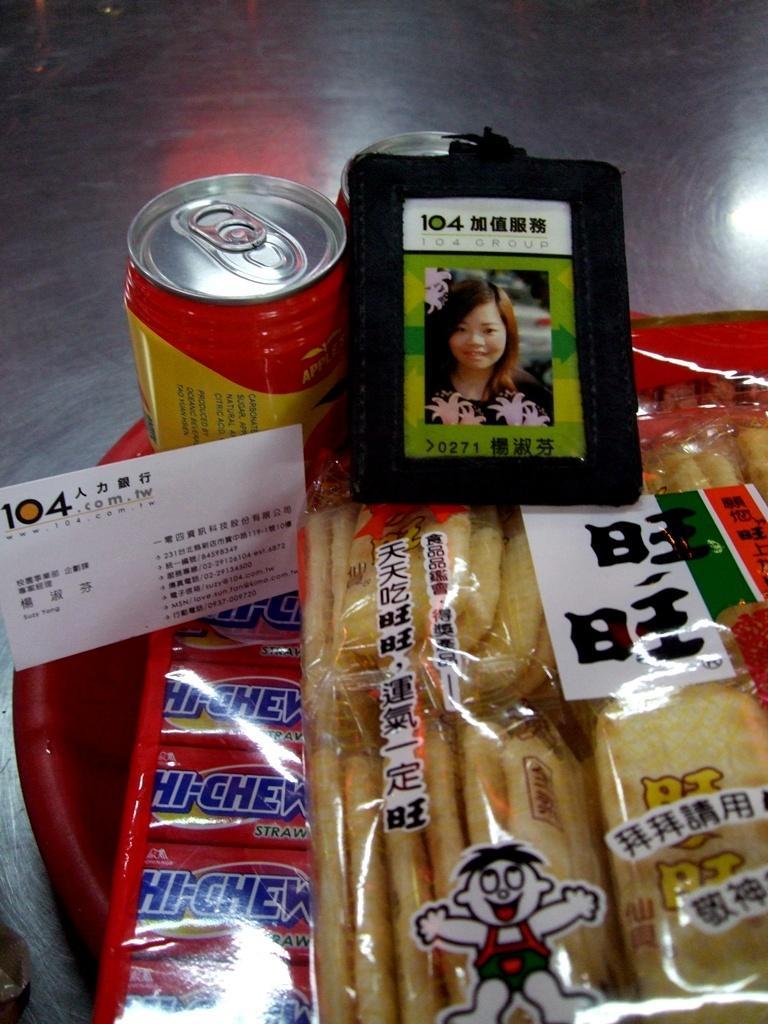How would you summarize this image in a sentence or two? In the image there is a basket full of chips packets,soft drinks and an id card on it. 